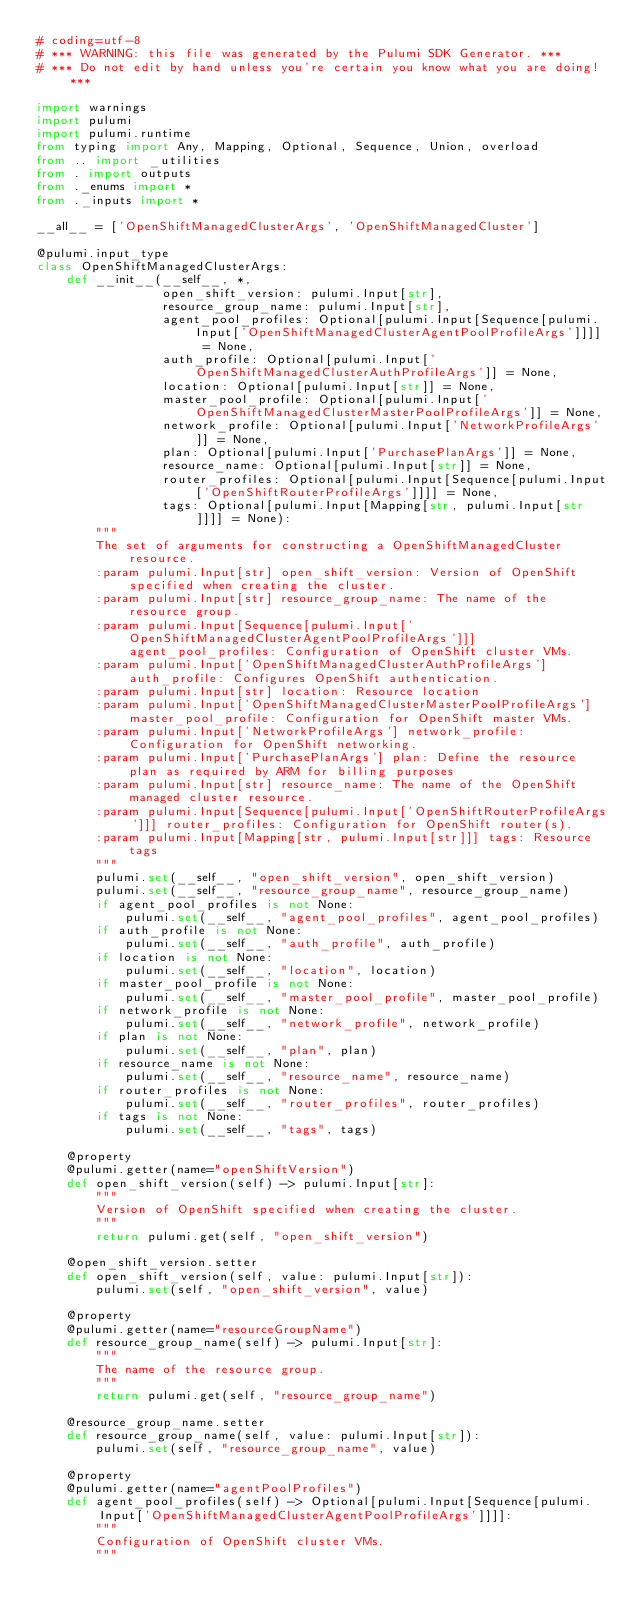Convert code to text. <code><loc_0><loc_0><loc_500><loc_500><_Python_># coding=utf-8
# *** WARNING: this file was generated by the Pulumi SDK Generator. ***
# *** Do not edit by hand unless you're certain you know what you are doing! ***

import warnings
import pulumi
import pulumi.runtime
from typing import Any, Mapping, Optional, Sequence, Union, overload
from .. import _utilities
from . import outputs
from ._enums import *
from ._inputs import *

__all__ = ['OpenShiftManagedClusterArgs', 'OpenShiftManagedCluster']

@pulumi.input_type
class OpenShiftManagedClusterArgs:
    def __init__(__self__, *,
                 open_shift_version: pulumi.Input[str],
                 resource_group_name: pulumi.Input[str],
                 agent_pool_profiles: Optional[pulumi.Input[Sequence[pulumi.Input['OpenShiftManagedClusterAgentPoolProfileArgs']]]] = None,
                 auth_profile: Optional[pulumi.Input['OpenShiftManagedClusterAuthProfileArgs']] = None,
                 location: Optional[pulumi.Input[str]] = None,
                 master_pool_profile: Optional[pulumi.Input['OpenShiftManagedClusterMasterPoolProfileArgs']] = None,
                 network_profile: Optional[pulumi.Input['NetworkProfileArgs']] = None,
                 plan: Optional[pulumi.Input['PurchasePlanArgs']] = None,
                 resource_name: Optional[pulumi.Input[str]] = None,
                 router_profiles: Optional[pulumi.Input[Sequence[pulumi.Input['OpenShiftRouterProfileArgs']]]] = None,
                 tags: Optional[pulumi.Input[Mapping[str, pulumi.Input[str]]]] = None):
        """
        The set of arguments for constructing a OpenShiftManagedCluster resource.
        :param pulumi.Input[str] open_shift_version: Version of OpenShift specified when creating the cluster.
        :param pulumi.Input[str] resource_group_name: The name of the resource group.
        :param pulumi.Input[Sequence[pulumi.Input['OpenShiftManagedClusterAgentPoolProfileArgs']]] agent_pool_profiles: Configuration of OpenShift cluster VMs.
        :param pulumi.Input['OpenShiftManagedClusterAuthProfileArgs'] auth_profile: Configures OpenShift authentication.
        :param pulumi.Input[str] location: Resource location
        :param pulumi.Input['OpenShiftManagedClusterMasterPoolProfileArgs'] master_pool_profile: Configuration for OpenShift master VMs.
        :param pulumi.Input['NetworkProfileArgs'] network_profile: Configuration for OpenShift networking.
        :param pulumi.Input['PurchasePlanArgs'] plan: Define the resource plan as required by ARM for billing purposes
        :param pulumi.Input[str] resource_name: The name of the OpenShift managed cluster resource.
        :param pulumi.Input[Sequence[pulumi.Input['OpenShiftRouterProfileArgs']]] router_profiles: Configuration for OpenShift router(s).
        :param pulumi.Input[Mapping[str, pulumi.Input[str]]] tags: Resource tags
        """
        pulumi.set(__self__, "open_shift_version", open_shift_version)
        pulumi.set(__self__, "resource_group_name", resource_group_name)
        if agent_pool_profiles is not None:
            pulumi.set(__self__, "agent_pool_profiles", agent_pool_profiles)
        if auth_profile is not None:
            pulumi.set(__self__, "auth_profile", auth_profile)
        if location is not None:
            pulumi.set(__self__, "location", location)
        if master_pool_profile is not None:
            pulumi.set(__self__, "master_pool_profile", master_pool_profile)
        if network_profile is not None:
            pulumi.set(__self__, "network_profile", network_profile)
        if plan is not None:
            pulumi.set(__self__, "plan", plan)
        if resource_name is not None:
            pulumi.set(__self__, "resource_name", resource_name)
        if router_profiles is not None:
            pulumi.set(__self__, "router_profiles", router_profiles)
        if tags is not None:
            pulumi.set(__self__, "tags", tags)

    @property
    @pulumi.getter(name="openShiftVersion")
    def open_shift_version(self) -> pulumi.Input[str]:
        """
        Version of OpenShift specified when creating the cluster.
        """
        return pulumi.get(self, "open_shift_version")

    @open_shift_version.setter
    def open_shift_version(self, value: pulumi.Input[str]):
        pulumi.set(self, "open_shift_version", value)

    @property
    @pulumi.getter(name="resourceGroupName")
    def resource_group_name(self) -> pulumi.Input[str]:
        """
        The name of the resource group.
        """
        return pulumi.get(self, "resource_group_name")

    @resource_group_name.setter
    def resource_group_name(self, value: pulumi.Input[str]):
        pulumi.set(self, "resource_group_name", value)

    @property
    @pulumi.getter(name="agentPoolProfiles")
    def agent_pool_profiles(self) -> Optional[pulumi.Input[Sequence[pulumi.Input['OpenShiftManagedClusterAgentPoolProfileArgs']]]]:
        """
        Configuration of OpenShift cluster VMs.
        """</code> 